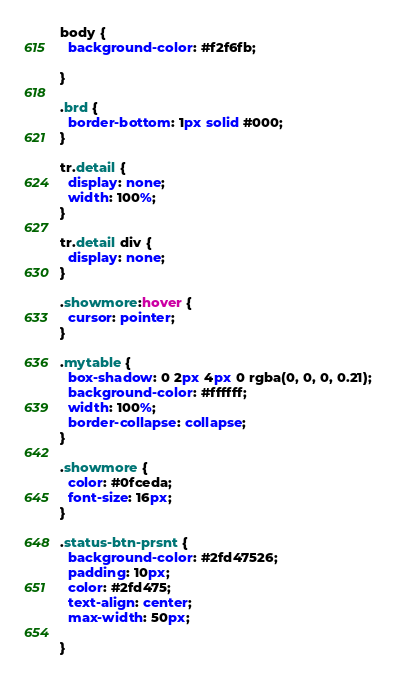<code> <loc_0><loc_0><loc_500><loc_500><_CSS_>body {
  background-color: #f2f6fb;

}

.brd {
  border-bottom: 1px solid #000;
}

tr.detail {
  display: none;
  width: 100%;
}

tr.detail div {
  display: none;
}

.showmore:hover {
  cursor: pointer;
}

.mytable {
  box-shadow: 0 2px 4px 0 rgba(0, 0, 0, 0.21);
  background-color: #ffffff;
  width: 100%;
  border-collapse: collapse;
}

.showmore {
  color: #0fceda;
  font-size: 16px;
}

.status-btn-prsnt {
  background-color: #2fd47526;
  padding: 10px;
  color: #2fd475;
  text-align: center;
  max-width: 50px;

}
</code> 